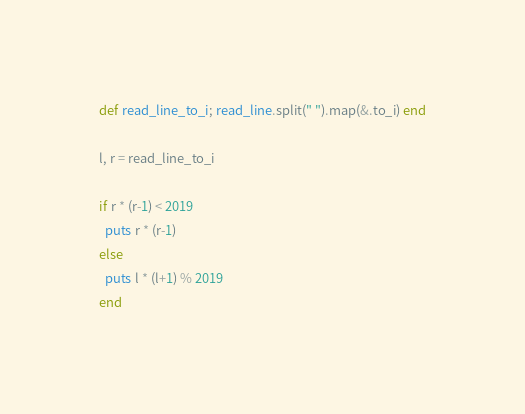<code> <loc_0><loc_0><loc_500><loc_500><_Crystal_>def read_line_to_i; read_line.split(" ").map(&.to_i) end

l, r = read_line_to_i

if r * (r-1) < 2019
  puts r * (r-1)
else
  puts l * (l+1) % 2019
end
</code> 